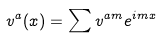Convert formula to latex. <formula><loc_0><loc_0><loc_500><loc_500>v ^ { a } ( x ) = \sum v ^ { a m } e ^ { i m x }</formula> 